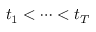Convert formula to latex. <formula><loc_0><loc_0><loc_500><loc_500>t _ { 1 } < \dots < t _ { T }</formula> 